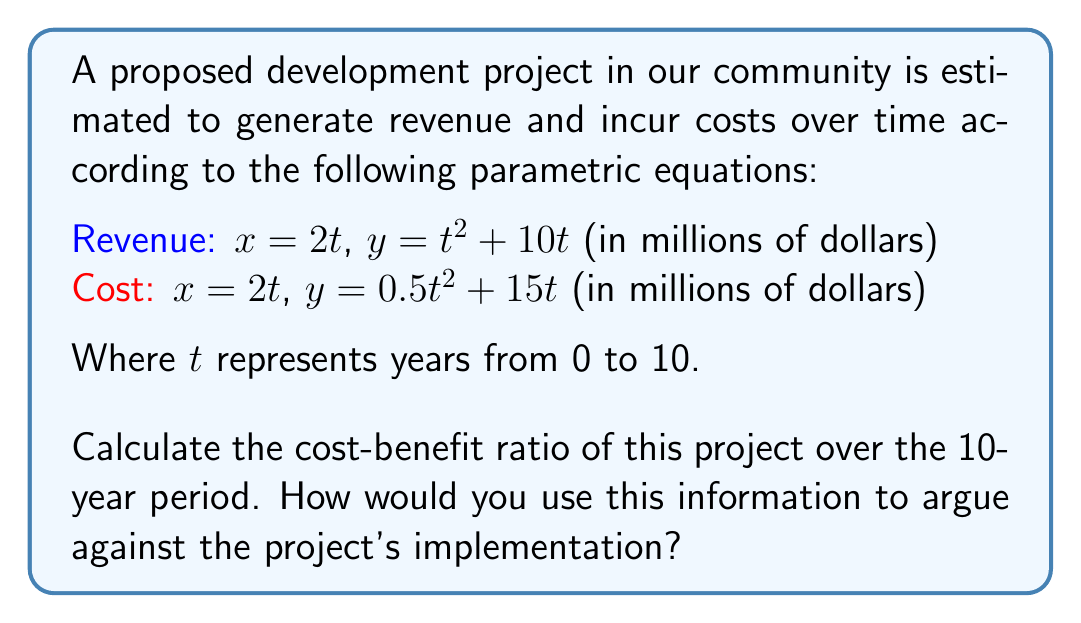Teach me how to tackle this problem. To calculate the cost-benefit ratio, we need to determine the total revenue and total cost over the 10-year period, then divide the total cost by the total revenue.

1) First, let's calculate the revenue and cost at $t = 10$:

   Revenue at $t = 10$: $x = 2(10) = 20$, $y = 10^2 + 10(10) = 200$
   Cost at $t = 10$: $x = 2(10) = 20$, $y = 0.5(10^2) + 15(10) = 200$

2) The area under each curve represents the total revenue and total cost over the 10-year period. We can calculate these using the integrals:

   Revenue: $\int_0^{20} (0.25x^2 + 5x) dx = [\frac{1}{12}x^3 + \frac{5}{2}x^2]_0^{20} = \frac{20^3}{12} + 50(20^2) = 666.67 + 20000 = 20666.67$

   Cost: $\int_0^{20} (0.125x^2 + 7.5x) dx = [\frac{1}{24}x^3 + \frac{15}{4}x^2]_0^{20} = \frac{20^3}{24} + \frac{15}{4}(20^2) = 333.33 + 15000 = 15333.33$

3) The cost-benefit ratio is:

   $\text{Cost-Benefit Ratio} = \frac{\text{Total Cost}}{\text{Total Revenue}} = \frac{15333.33}{20666.67} \approx 0.7419$

4) To argue against the project:
   - While the ratio is less than 1, indicating potential profitability, it's close to 0.75, meaning costs are about 75% of revenues.
   - This leaves little room for unexpected expenses or revenue shortfalls.
   - The high costs relative to revenue could lead to increased taxes to cover potential shortfalls.
   - The project doesn't provide a significant enough benefit to justify the risks and potential tax burden on the community.
Answer: The cost-benefit ratio of the project over the 10-year period is approximately 0.7419, or 74.19%. This high ratio indicates that the project's costs are nearly 75% of its revenues, leaving little room for error and potentially burdening the local community with high risks and possible tax increases. 